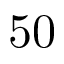Convert formula to latex. <formula><loc_0><loc_0><loc_500><loc_500>5 0</formula> 